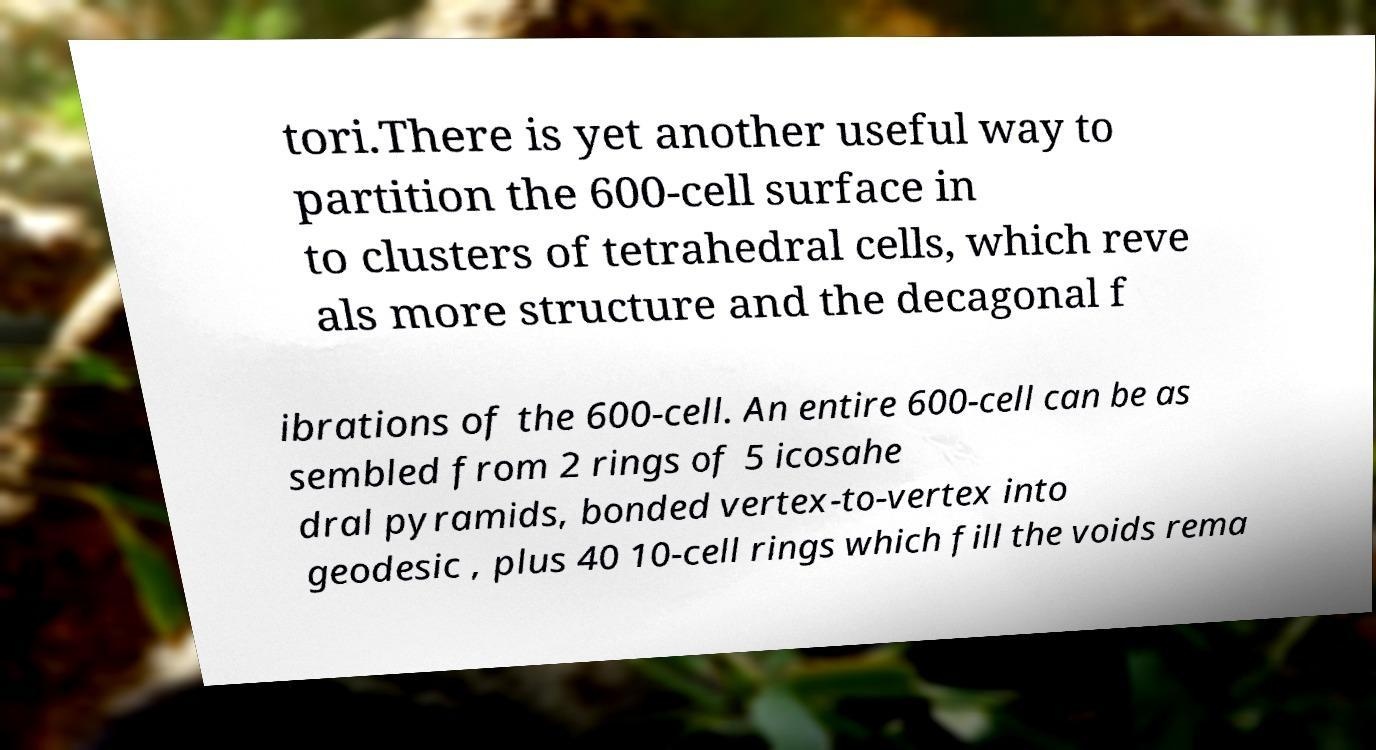Please read and relay the text visible in this image. What does it say? tori.There is yet another useful way to partition the 600-cell surface in to clusters of tetrahedral cells, which reve als more structure and the decagonal f ibrations of the 600-cell. An entire 600-cell can be as sembled from 2 rings of 5 icosahe dral pyramids, bonded vertex-to-vertex into geodesic , plus 40 10-cell rings which fill the voids rema 